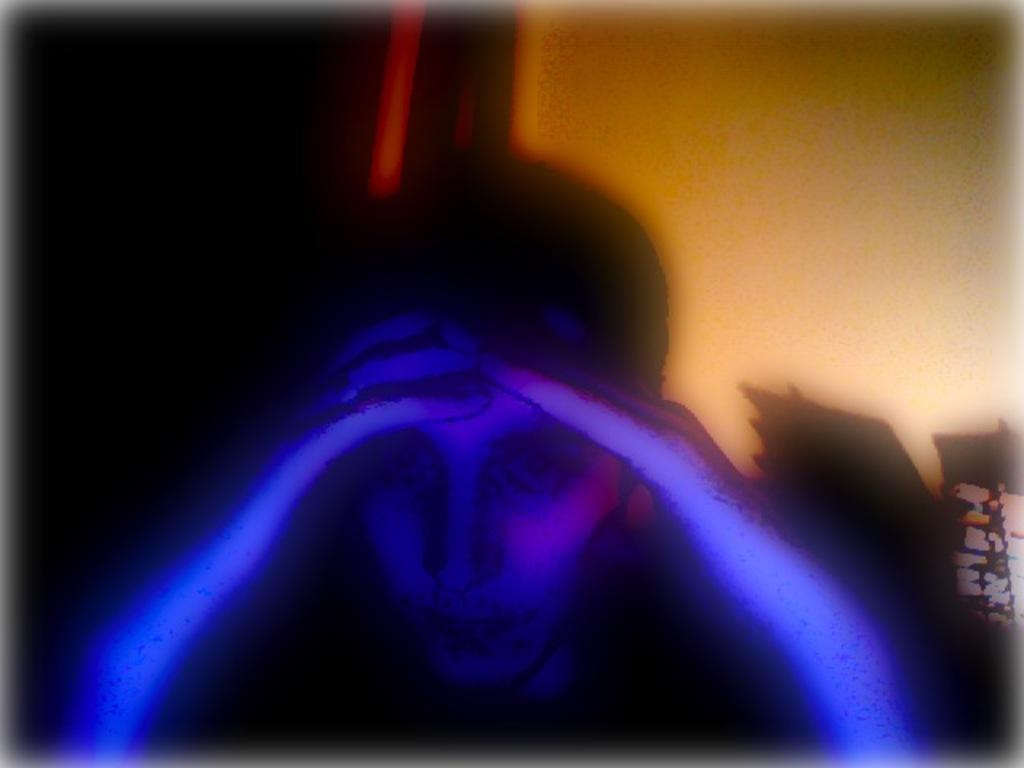Who is present in the image? There is a boy in the image. What can be seen in the background of the image? There is a wall in the image. What is the boy's tendency to burst into song in the image? There is no information about the boy's tendency to burst into song in the image. 